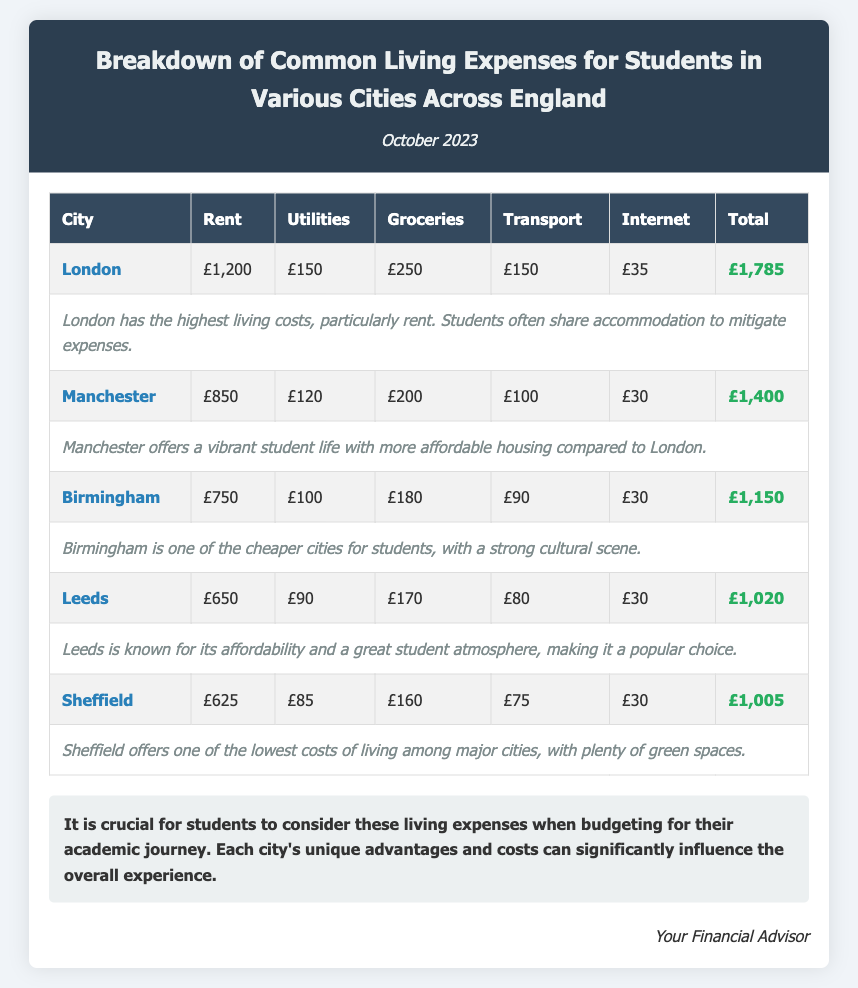What is the city with the highest living costs? The document states that London has the highest living costs among all the cities listed.
Answer: London What is the total living expense for Birmingham? The total living expense for Birmingham is provided in the table, which is £1,150.
Answer: £1,150 How much does internet cost in Sheffield? The document lists the internet costs for each city, and for Sheffield, it is £30.
Answer: £30 What is the rent cost in Manchester? The rent cost for Manchester is stated as £850 in the document.
Answer: £850 Which city has the lowest total living expenses? The comparison of total living expenses shows that Sheffield has the lowest total living expenses at £1,005.
Answer: £1,005 What is noted about London's accommodation? The comments section indicates that students often share accommodation in London to mitigate expenses.
Answer: Share accommodation What is the monthly transport cost in Leeds? The document specifies that the transport cost in Leeds is £80.
Answer: £80 What conclusion is drawn about budgeting for students? The conclusion emphasizes the importance of considering living expenses when budgeting for academic journeys.
Answer: Important for budgeting 